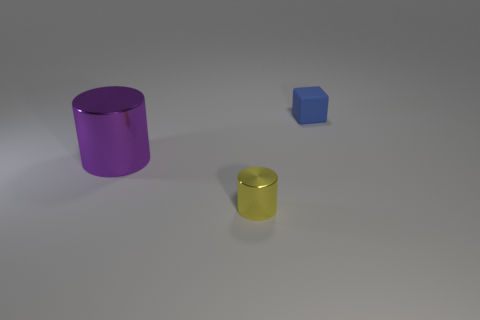Are there any other things that have the same material as the blue thing?
Offer a very short reply. No. What is the purple object made of?
Provide a succinct answer. Metal. How many rubber objects are the same size as the yellow cylinder?
Provide a succinct answer. 1. Are there any other purple things that have the same shape as the small metal thing?
Ensure brevity in your answer.  Yes. The cylinder that is the same size as the matte thing is what color?
Ensure brevity in your answer.  Yellow. There is a cylinder that is to the left of the small thing that is in front of the small blue matte thing; what is its color?
Your answer should be very brief. Purple. What is the shape of the small thing that is behind the shiny object that is to the left of the thing in front of the large purple cylinder?
Make the answer very short. Cube. How many things are to the left of the small object that is behind the large purple metal cylinder?
Your answer should be compact. 2. Do the tiny cylinder and the large cylinder have the same material?
Your response must be concise. Yes. There is a small thing behind the thing that is in front of the purple metallic cylinder; what number of tiny blue cubes are left of it?
Your answer should be very brief. 0. 